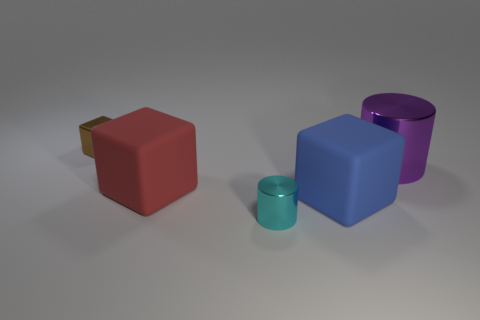What number of shiny things have the same color as the metallic cube?
Keep it short and to the point. 0. How many other objects are there of the same color as the small block?
Ensure brevity in your answer.  0. Are there more cyan cylinders than large matte blocks?
Your answer should be compact. No. What material is the tiny cyan object?
Your answer should be compact. Metal. Is the size of the shiny cylinder that is to the right of the blue rubber cube the same as the tiny cyan cylinder?
Keep it short and to the point. No. There is a red rubber block in front of the purple object; how big is it?
Make the answer very short. Large. Are there any other things that have the same material as the cyan cylinder?
Keep it short and to the point. Yes. How many red rubber blocks are there?
Your answer should be compact. 1. There is a metal thing that is both on the left side of the large metallic thing and behind the small cyan cylinder; what is its color?
Make the answer very short. Brown. Are there any small metal objects behind the purple shiny cylinder?
Your answer should be very brief. Yes. 